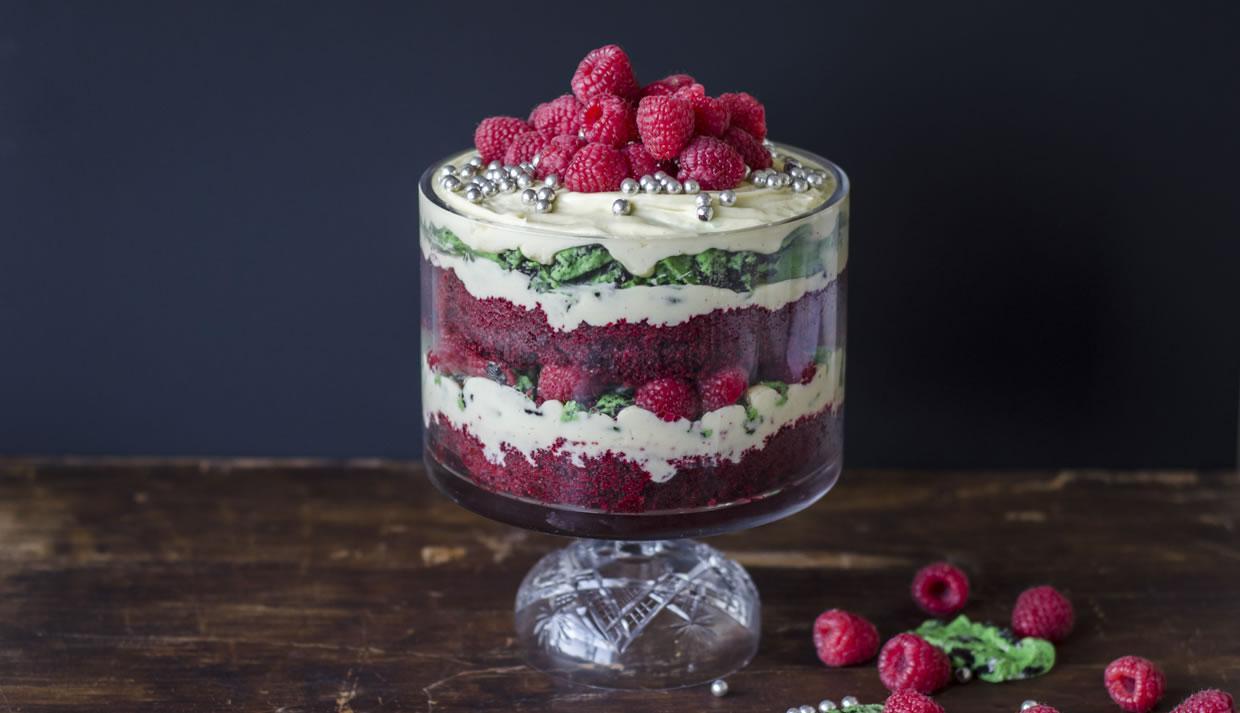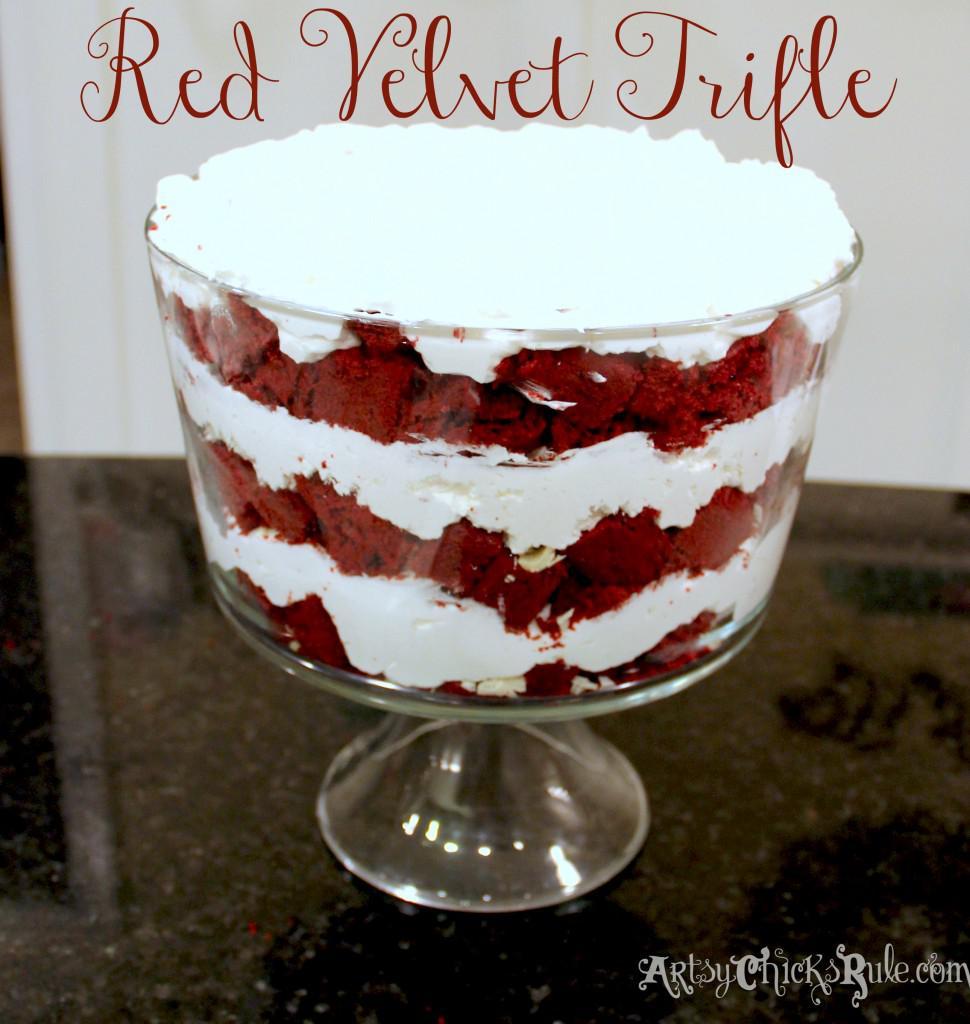The first image is the image on the left, the second image is the image on the right. Examine the images to the left and right. Is the description "Each dessert is being served in a large glass family sized portion." accurate? Answer yes or no. Yes. The first image is the image on the left, the second image is the image on the right. For the images shown, is this caption "Whole red raspberries garnish the top of at least one layered dessert served in a clear glass dish." true? Answer yes or no. Yes. 